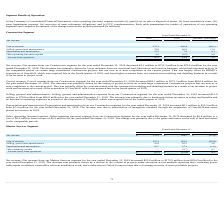According to Hc2 Holdings's financial document, What was the net revenue from Marine Services segment for the year ended December 31, 2019? According to the financial document, $713.3 million. The relevant text states: "ended December 31, 2019 decreased $3.1 million to $713.3 million from $716.4 million for the year ended December 31, 2018. The decrease was primarily driven by lower..." Also, What was the net revenue from Marine Services segment for the year ended December 31, 2018? According to the financial document, $716.4 million. The relevant text states: "2019 decreased $3.1 million to $713.3 million from $716.4 million for the year ended December 31, 2018. The decrease was primarily driven by lower revenues from our s..." Also, What was the cost of revenue from Marine Services segment for the year ended December 31, 2019? According to the financial document, $572.3 million. The relevant text states: "ended December 31, 2019 decreased $28.1 million to $572.3 million from $600.4 million for the year ended December 31, 2018. The decrease was primarily driven by the t..." Also, can you calculate: What was the percentage change in the net revenue from 2018 to 2019? To answer this question, I need to perform calculations using the financial data. The calculation is: 713.3 / 716.4 - 1, which equals -0.43 (percentage). This is based on the information: "Net revenue $ 713.3 $ 716.4 $ (3.1) Net revenue $ 713.3 $ 716.4 $ (3.1)..." The key data points involved are: 713.3, 716.4. Also, can you calculate: What was the average cost of revenue for 2018 and 2019? To answer this question, I need to perform calculations using the financial data. The calculation is: (572.3 + 600.4) / 2, which equals 586.35 (in millions). This is based on the information: "Cost of revenue 572.3 600.4 (28.1) Cost of revenue 572.3 600.4 (28.1)..." The key data points involved are: 572.3, 600.4. Also, can you calculate: What is the percentage change in the Depreciation and amortization from 2018 to 2019? To answer this question, I need to perform calculations using the financial data. The calculation is: (15.5 / 7.4 - 1), which equals 109.46 (percentage). This is based on the information: "Depreciation and amortization 15.5 7.4 8.1 Depreciation and amortization 15.5 7.4 8.1..." The key data points involved are: 15.5, 7.4. 